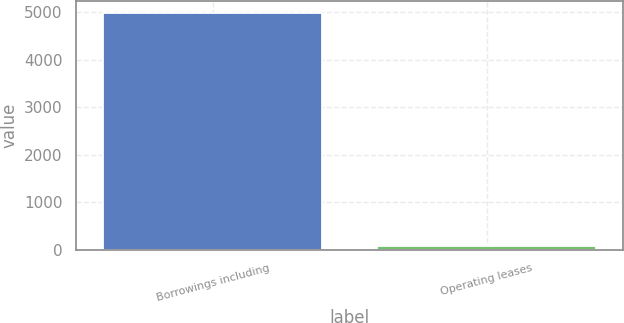<chart> <loc_0><loc_0><loc_500><loc_500><bar_chart><fcel>Borrowings including<fcel>Operating leases<nl><fcel>4986.3<fcel>85.1<nl></chart> 